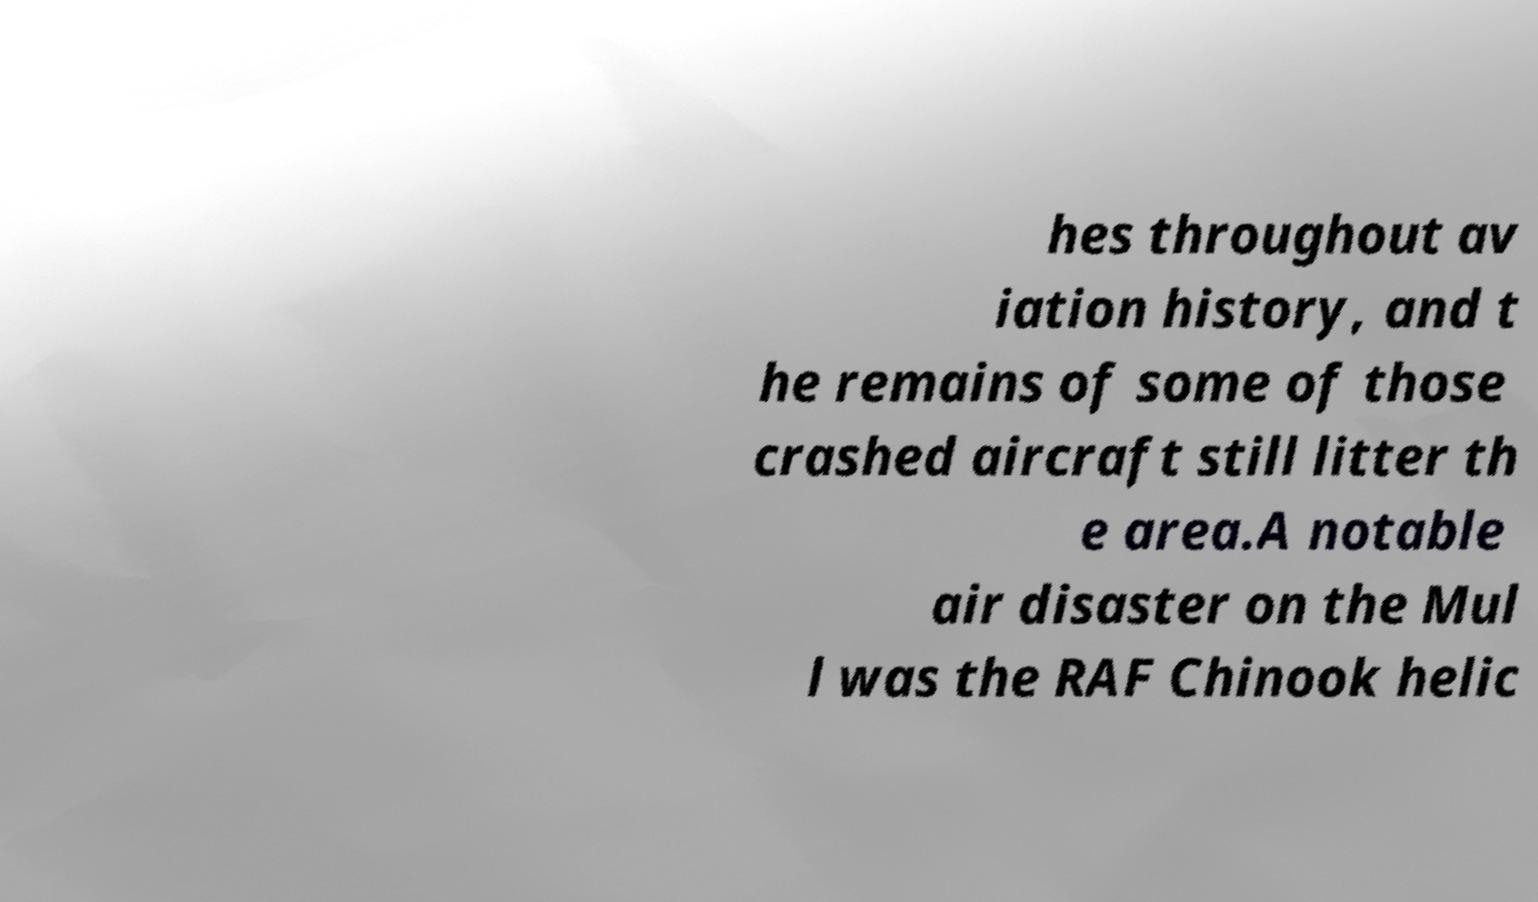Please read and relay the text visible in this image. What does it say? hes throughout av iation history, and t he remains of some of those crashed aircraft still litter th e area.A notable air disaster on the Mul l was the RAF Chinook helic 